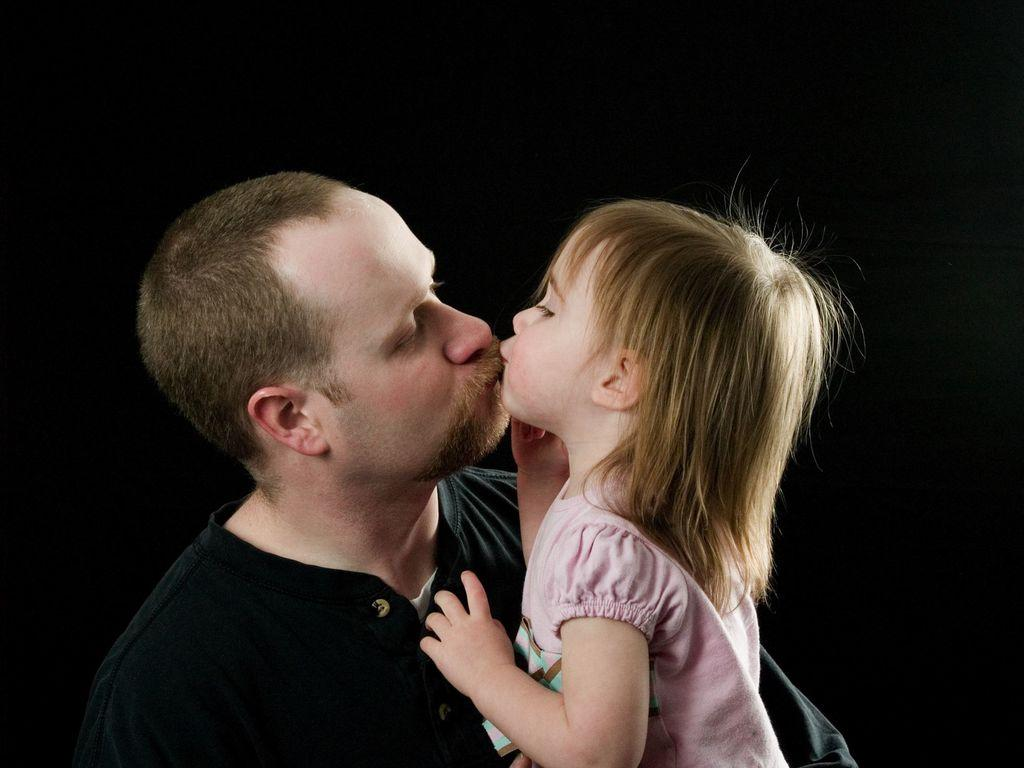Who is the main subject in the image? There is a man in the image. What is the man wearing? The man is wearing a black t-shirt. What is the man doing in the image? The man is holding a girl. What is the girl wearing in the image? The girl is wearing a pink dress. How would you describe the lighting in the image? The top part of the image appears to be dark. What type of cork can be seen in the image? There is no cork present in the image. Can you describe the kiss between the man and the girl in the image? There is no kiss depicted in the image; the man is simply holding the girl. 